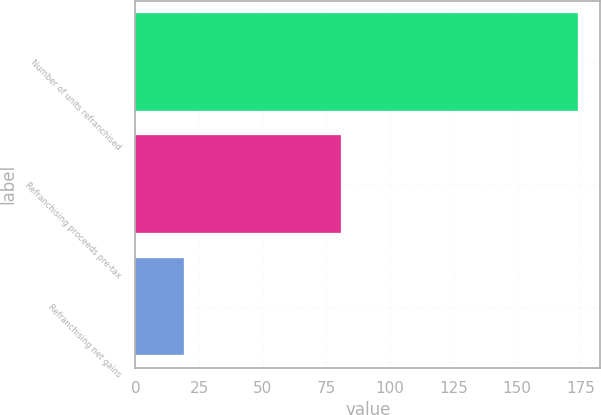Convert chart. <chart><loc_0><loc_0><loc_500><loc_500><bar_chart><fcel>Number of units refranchised<fcel>Refranchising proceeds pre-tax<fcel>Refranchising net gains<nl><fcel>174<fcel>81<fcel>19<nl></chart> 